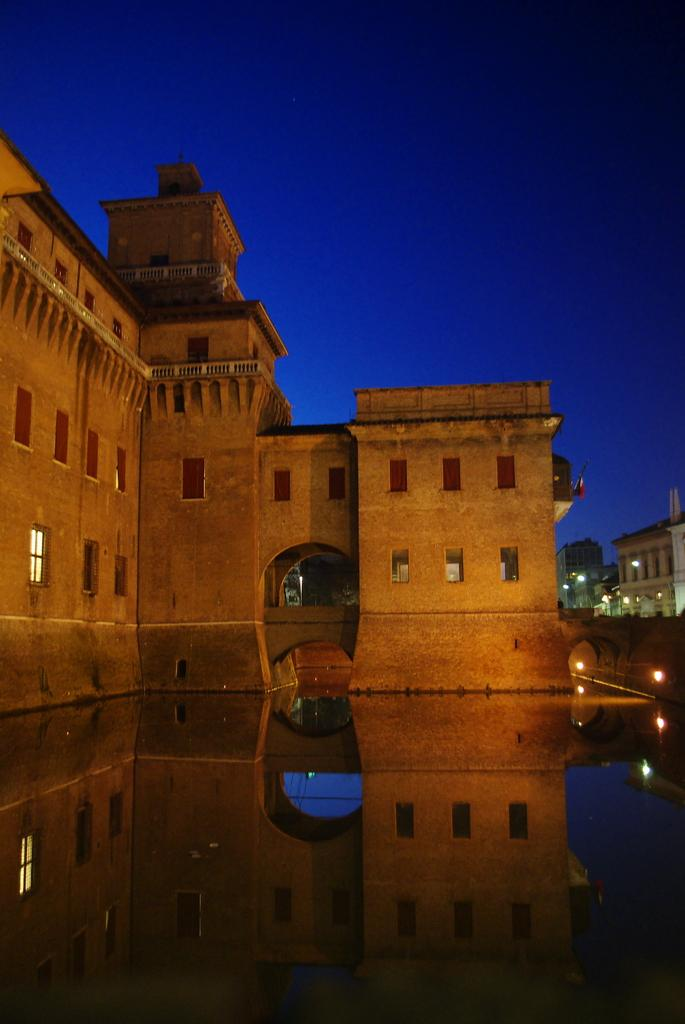What is in the foreground of the image? There is water in the foreground of the image. What is unusual about the building in the image? The building is in the water. What can be seen in the background of the image besides the sky? There are buildings visible in the background of the image. What is visible above the buildings in the background? The sky is visible in the background of the image. What flavor of cord can be seen hanging from the building in the image? There is no cord present in the image, and therefore no flavor can be determined. 